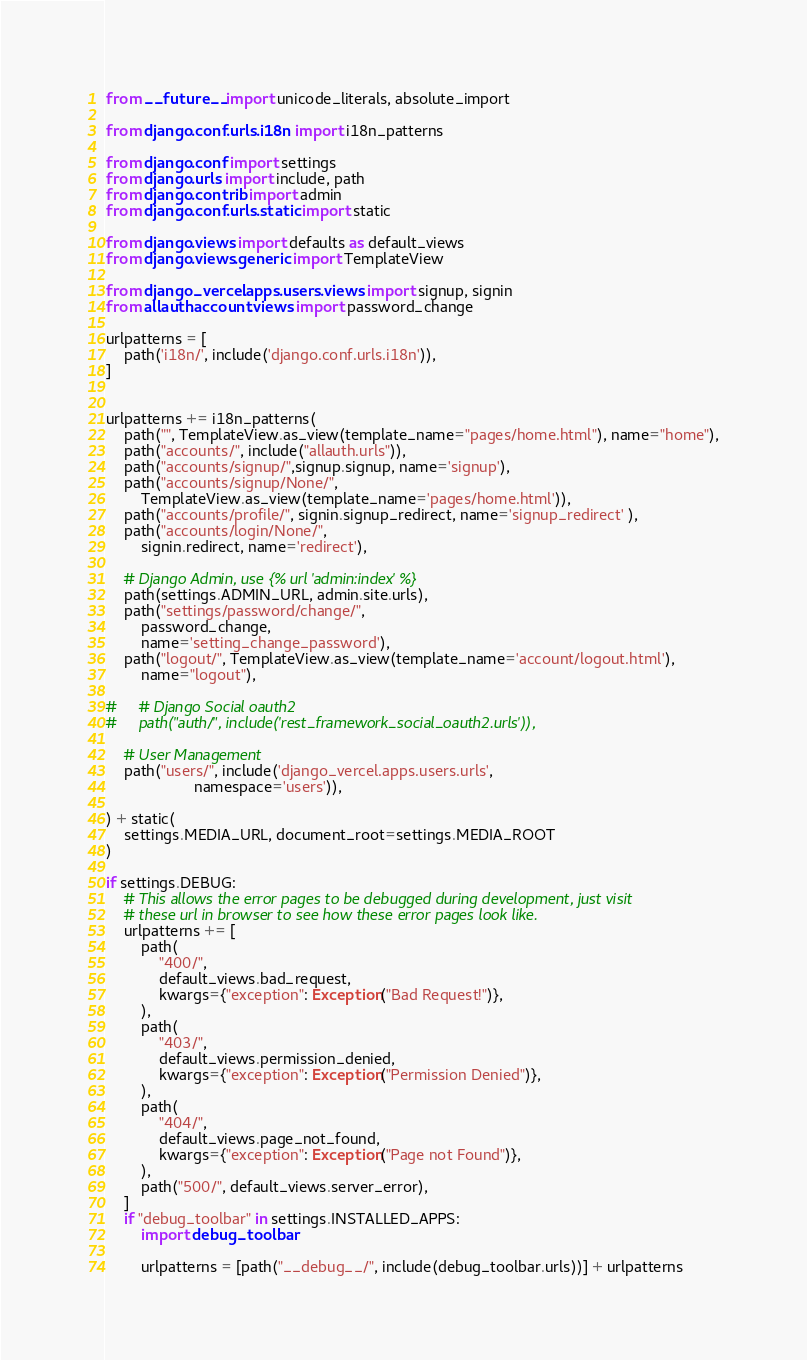<code> <loc_0><loc_0><loc_500><loc_500><_Python_>from __future__ import unicode_literals, absolute_import

from django.conf.urls.i18n import i18n_patterns

from django.conf import settings
from django.urls import include, path
from django.contrib import admin
from django.conf.urls.static import static

from django.views import defaults as default_views
from django.views.generic import TemplateView

from django_vercel.apps.users.views import signup, signin
from allauth.account.views import password_change

urlpatterns = [
    path('i18n/', include('django.conf.urls.i18n')),
]


urlpatterns += i18n_patterns(
    path("", TemplateView.as_view(template_name="pages/home.html"), name="home"),
    path("accounts/", include("allauth.urls")),
    path("accounts/signup/",signup.signup, name='signup'),
    path("accounts/signup/None/", 
        TemplateView.as_view(template_name='pages/home.html')),
    path("accounts/profile/", signin.signup_redirect, name='signup_redirect' ),
    path("accounts/login/None/", 
        signin.redirect, name='redirect'),
         
    # Django Admin, use {% url 'admin:index' %}
    path(settings.ADMIN_URL, admin.site.urls),
    path("settings/password/change/", 
        password_change, 
        name='setting_change_password'),
    path("logout/", TemplateView.as_view(template_name='account/logout.html'), 
        name="logout"),
        
#     # Django Social oauth2
#     path("auth/", include('rest_framework_social_oauth2.urls')),
    
    # User Management
    path("users/", include('django_vercel.apps.users.urls', 
                    namespace='users')),

) + static(
    settings.MEDIA_URL, document_root=settings.MEDIA_ROOT
)

if settings.DEBUG:
    # This allows the error pages to be debugged during development, just visit
    # these url in browser to see how these error pages look like.
    urlpatterns += [
        path(
            "400/",
            default_views.bad_request,
            kwargs={"exception": Exception("Bad Request!")},
        ),
        path(
            "403/",
            default_views.permission_denied,
            kwargs={"exception": Exception("Permission Denied")},
        ),
        path(
            "404/",
            default_views.page_not_found,
            kwargs={"exception": Exception("Page not Found")},
        ),
        path("500/", default_views.server_error),
    ]
    if "debug_toolbar" in settings.INSTALLED_APPS:
        import debug_toolbar

        urlpatterns = [path("__debug__/", include(debug_toolbar.urls))] + urlpatterns
</code> 